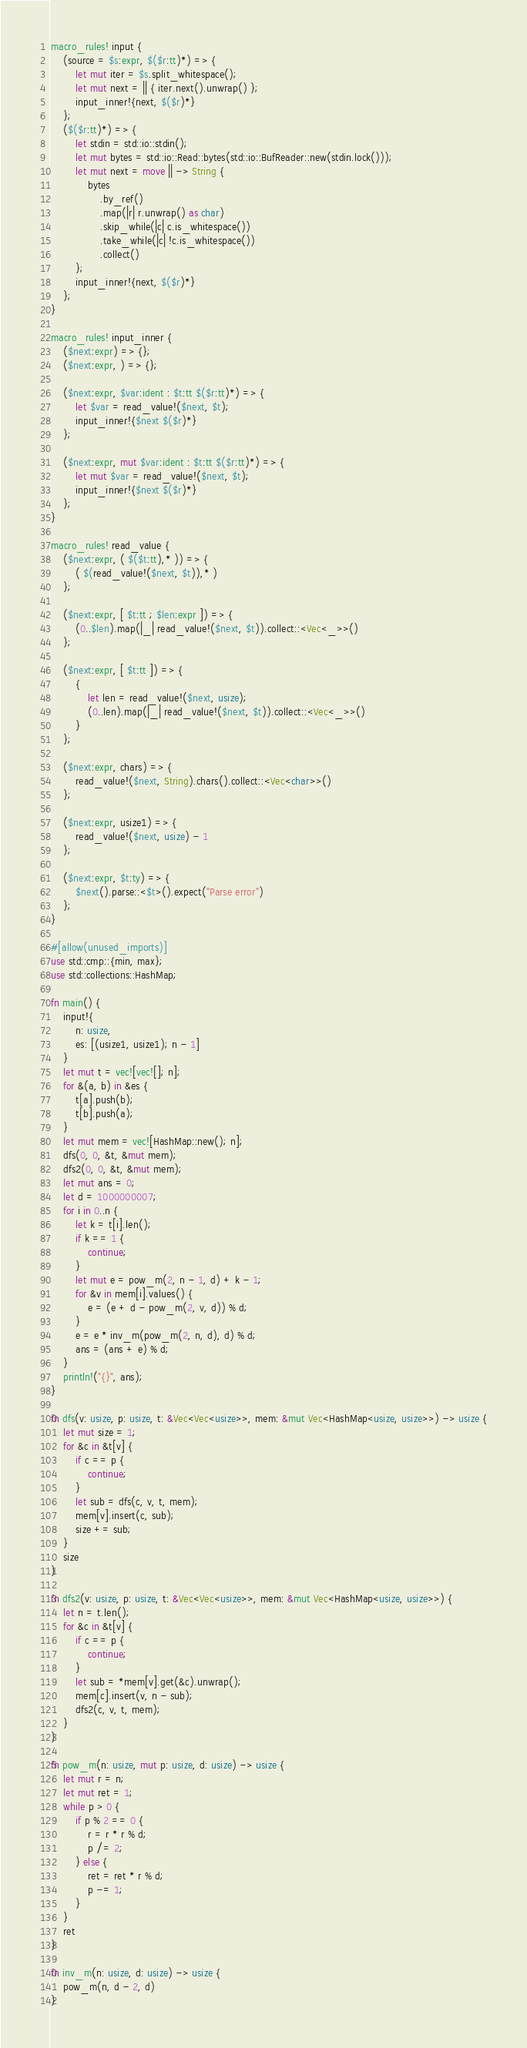Convert code to text. <code><loc_0><loc_0><loc_500><loc_500><_Rust_>macro_rules! input {
    (source = $s:expr, $($r:tt)*) => {
        let mut iter = $s.split_whitespace();
        let mut next = || { iter.next().unwrap() };
        input_inner!{next, $($r)*}
    };
    ($($r:tt)*) => {
        let stdin = std::io::stdin();
        let mut bytes = std::io::Read::bytes(std::io::BufReader::new(stdin.lock()));
        let mut next = move || -> String {
            bytes
                .by_ref()
                .map(|r| r.unwrap() as char)
                .skip_while(|c| c.is_whitespace())
                .take_while(|c| !c.is_whitespace())
                .collect()
        };
        input_inner!{next, $($r)*}
    };
}

macro_rules! input_inner {
    ($next:expr) => {};
    ($next:expr, ) => {};

    ($next:expr, $var:ident : $t:tt $($r:tt)*) => {
        let $var = read_value!($next, $t);
        input_inner!{$next $($r)*}
    };

    ($next:expr, mut $var:ident : $t:tt $($r:tt)*) => {
        let mut $var = read_value!($next, $t);
        input_inner!{$next $($r)*}
    };
}

macro_rules! read_value {
    ($next:expr, ( $($t:tt),* )) => {
        ( $(read_value!($next, $t)),* )
    };

    ($next:expr, [ $t:tt ; $len:expr ]) => {
        (0..$len).map(|_| read_value!($next, $t)).collect::<Vec<_>>()
    };

    ($next:expr, [ $t:tt ]) => {
        {
            let len = read_value!($next, usize);
            (0..len).map(|_| read_value!($next, $t)).collect::<Vec<_>>()
        }
    };

    ($next:expr, chars) => {
        read_value!($next, String).chars().collect::<Vec<char>>()
    };

    ($next:expr, usize1) => {
        read_value!($next, usize) - 1
    };

    ($next:expr, $t:ty) => {
        $next().parse::<$t>().expect("Parse error")
    };
}

#[allow(unused_imports)]
use std::cmp::{min, max};
use std::collections::HashMap;

fn main() {
    input!{
        n: usize,
        es: [(usize1, usize1); n - 1]
    }
    let mut t = vec![vec![]; n];
    for &(a, b) in &es {
        t[a].push(b);
        t[b].push(a);
    }
    let mut mem = vec![HashMap::new(); n];
    dfs(0, 0, &t, &mut mem);
    dfs2(0, 0, &t, &mut mem);
    let mut ans = 0;
    let d = 1000000007;
    for i in 0..n {
        let k = t[i].len();
        if k == 1 {
            continue;
        }
        let mut e = pow_m(2, n - 1, d) + k - 1;
        for &v in mem[i].values() {
            e = (e + d - pow_m(2, v, d)) % d;
        }
        e = e * inv_m(pow_m(2, n, d), d) % d;
        ans = (ans + e) % d;
    }
    println!("{}", ans);
}

fn dfs(v: usize, p: usize, t: &Vec<Vec<usize>>, mem: &mut Vec<HashMap<usize, usize>>) -> usize {
    let mut size = 1;
    for &c in &t[v] {
        if c == p {
            continue;
        }
        let sub = dfs(c, v, t, mem);
        mem[v].insert(c, sub);
        size += sub;
    }
    size
}

fn dfs2(v: usize, p: usize, t: &Vec<Vec<usize>>, mem: &mut Vec<HashMap<usize, usize>>) {
    let n = t.len();
    for &c in &t[v] {
        if c == p {
            continue;
        }
        let sub = *mem[v].get(&c).unwrap();
        mem[c].insert(v, n - sub);
        dfs2(c, v, t, mem);
    }
}

fn pow_m(n: usize, mut p: usize, d: usize) -> usize {
    let mut r = n;
    let mut ret = 1;
    while p > 0 {
        if p % 2 == 0 {
            r = r * r % d;
            p /= 2;
        } else {
            ret = ret * r % d;
            p -= 1;
        }
    }
    ret
}

fn inv_m(n: usize, d: usize) -> usize {
    pow_m(n, d - 2, d)
}
</code> 